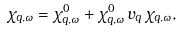Convert formula to latex. <formula><loc_0><loc_0><loc_500><loc_500>\chi _ { { q } , \omega } = \chi ^ { 0 } _ { { q } , \omega } + \chi ^ { 0 } _ { { q } , \omega } \, v _ { q } \, \chi _ { { q } , \omega } ,</formula> 